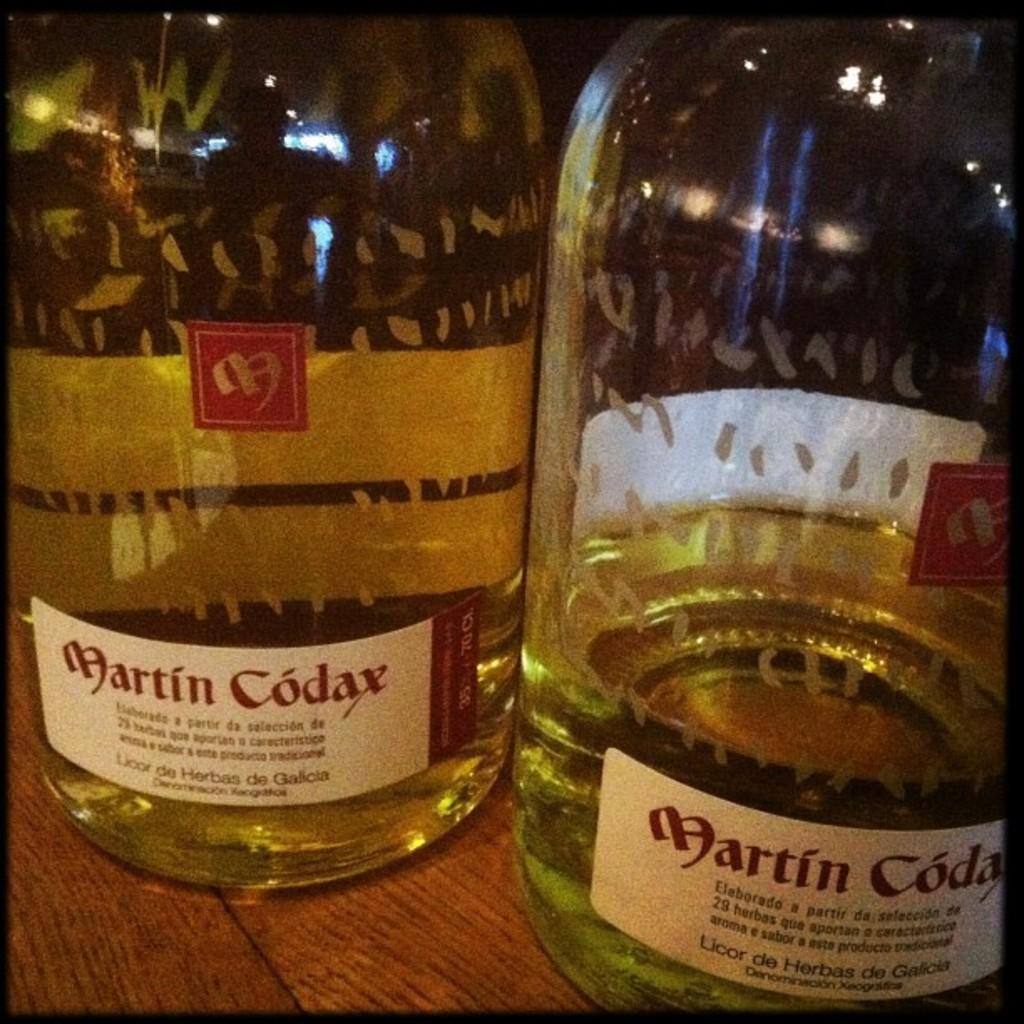<image>
Describe the image concisely. Two bottles of alcohol have labels reading Martin Codax. 